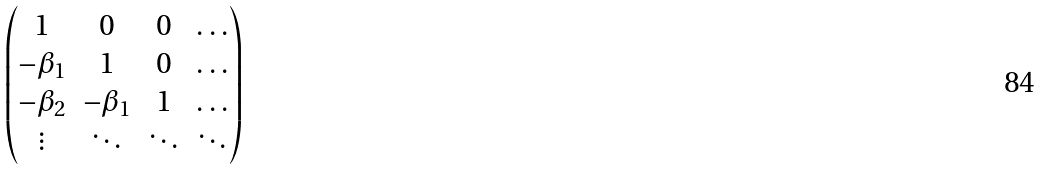Convert formula to latex. <formula><loc_0><loc_0><loc_500><loc_500>\begin{pmatrix} 1 & 0 & 0 & \dots \\ - \beta _ { 1 } & 1 & 0 & \dots \\ - \beta _ { 2 } & - \beta _ { 1 } & 1 & \dots \\ \vdots & \ddots & \ddots & \ddots \end{pmatrix}</formula> 